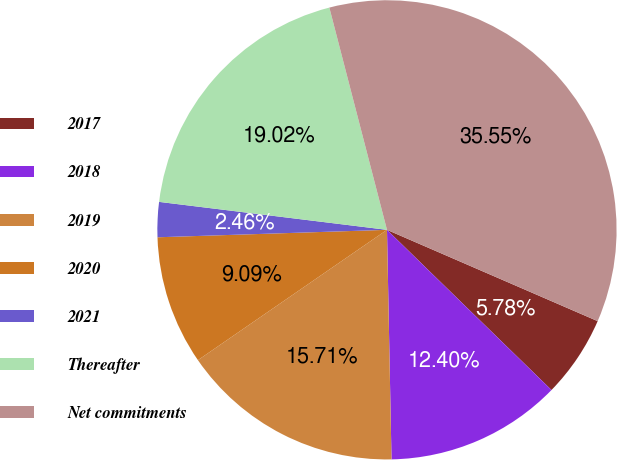Convert chart. <chart><loc_0><loc_0><loc_500><loc_500><pie_chart><fcel>2017<fcel>2018<fcel>2019<fcel>2020<fcel>2021<fcel>Thereafter<fcel>Net commitments<nl><fcel>5.78%<fcel>12.4%<fcel>15.71%<fcel>9.09%<fcel>2.46%<fcel>19.02%<fcel>35.55%<nl></chart> 